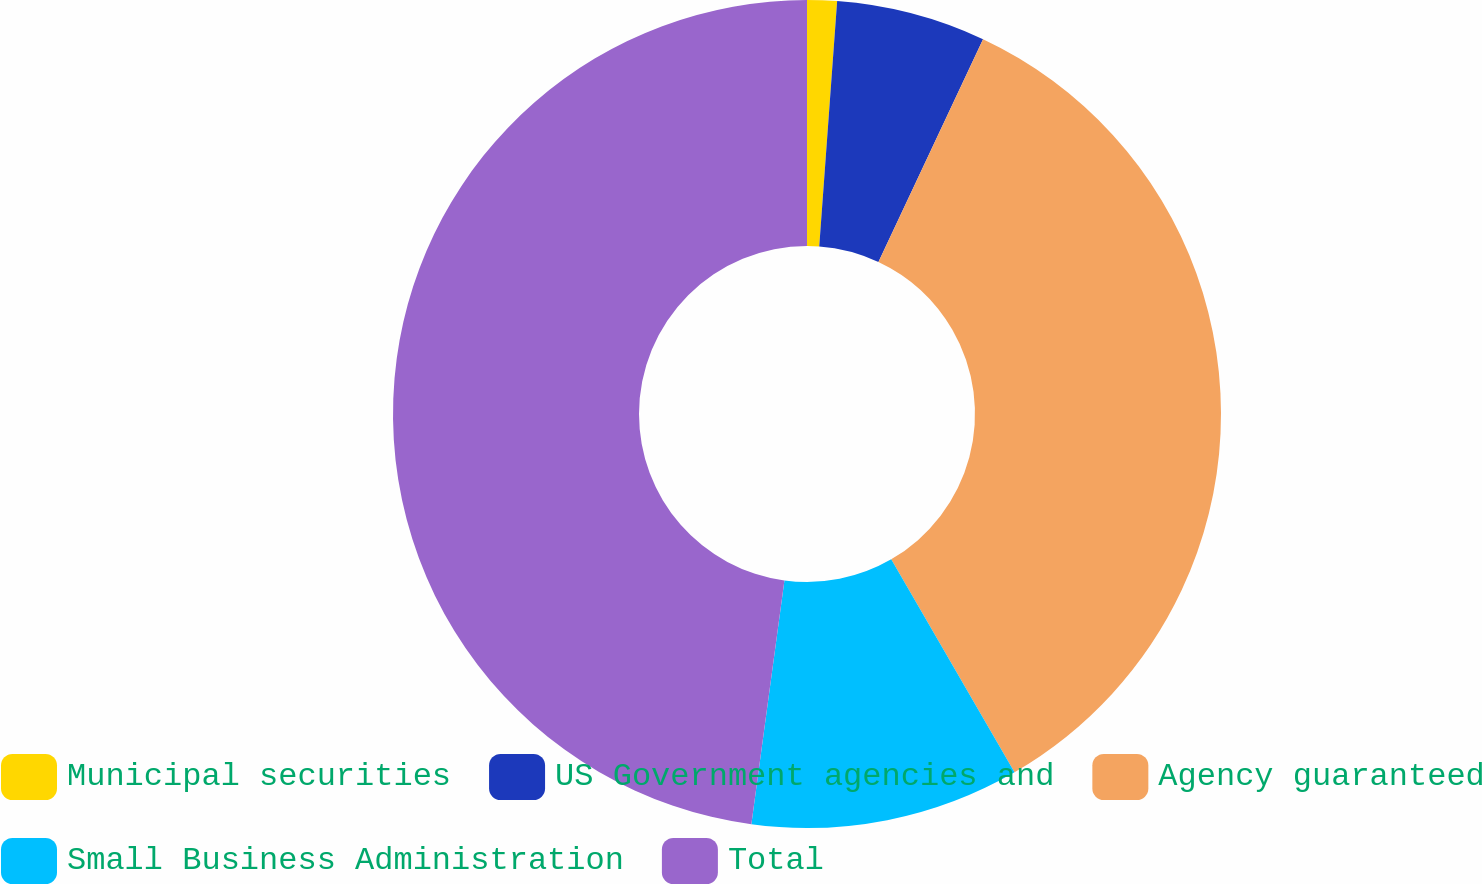Convert chart to OTSL. <chart><loc_0><loc_0><loc_500><loc_500><pie_chart><fcel>Municipal securities<fcel>US Government agencies and<fcel>Agency guaranteed<fcel>Small Business Administration<fcel>Total<nl><fcel>1.16%<fcel>5.83%<fcel>34.65%<fcel>10.5%<fcel>47.85%<nl></chart> 